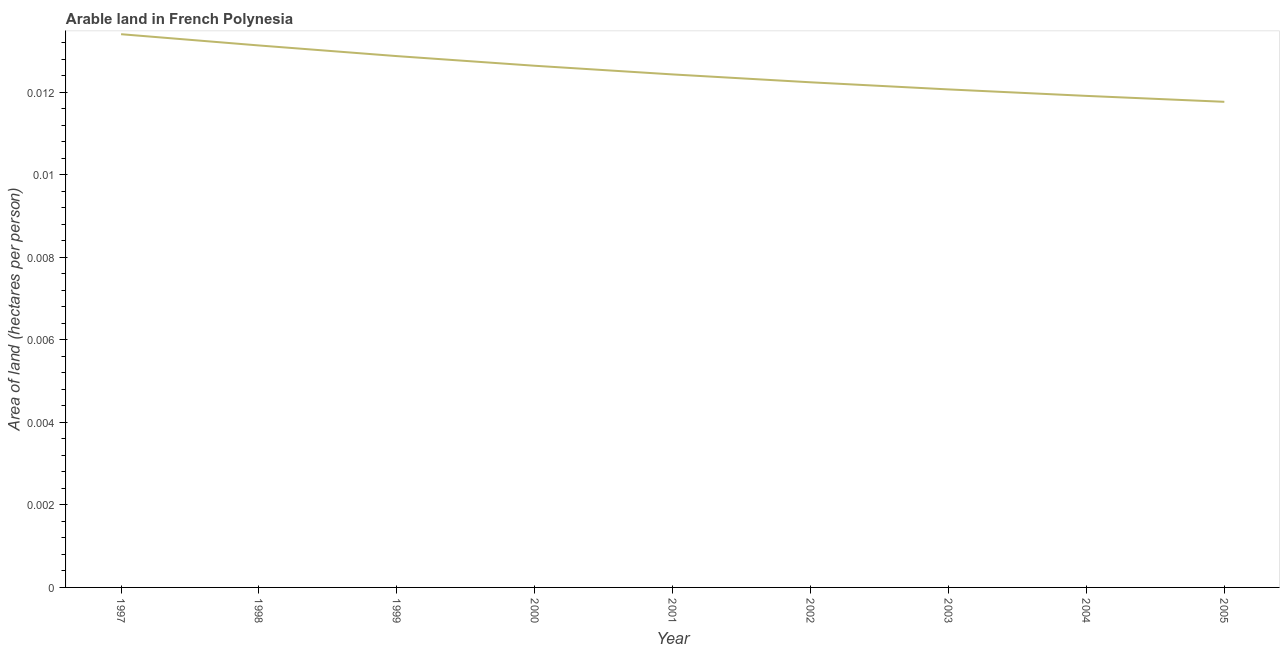What is the area of arable land in 2004?
Ensure brevity in your answer.  0.01. Across all years, what is the maximum area of arable land?
Your response must be concise. 0.01. Across all years, what is the minimum area of arable land?
Give a very brief answer. 0.01. In which year was the area of arable land maximum?
Provide a short and direct response. 1997. What is the sum of the area of arable land?
Your response must be concise. 0.11. What is the difference between the area of arable land in 1999 and 2003?
Provide a short and direct response. 0. What is the average area of arable land per year?
Offer a very short reply. 0.01. What is the median area of arable land?
Your answer should be compact. 0.01. In how many years, is the area of arable land greater than 0.0056 hectares per person?
Provide a succinct answer. 9. Do a majority of the years between 2001 and 2005 (inclusive) have area of arable land greater than 0.0052 hectares per person?
Provide a short and direct response. Yes. What is the ratio of the area of arable land in 1997 to that in 1999?
Ensure brevity in your answer.  1.04. Is the difference between the area of arable land in 1998 and 2005 greater than the difference between any two years?
Ensure brevity in your answer.  No. What is the difference between the highest and the second highest area of arable land?
Ensure brevity in your answer.  0. What is the difference between the highest and the lowest area of arable land?
Your answer should be very brief. 0. In how many years, is the area of arable land greater than the average area of arable land taken over all years?
Give a very brief answer. 4. What is the difference between two consecutive major ticks on the Y-axis?
Your answer should be compact. 0. Are the values on the major ticks of Y-axis written in scientific E-notation?
Provide a short and direct response. No. Does the graph contain any zero values?
Make the answer very short. No. Does the graph contain grids?
Give a very brief answer. No. What is the title of the graph?
Provide a succinct answer. Arable land in French Polynesia. What is the label or title of the Y-axis?
Your response must be concise. Area of land (hectares per person). What is the Area of land (hectares per person) of 1997?
Keep it short and to the point. 0.01. What is the Area of land (hectares per person) of 1998?
Provide a short and direct response. 0.01. What is the Area of land (hectares per person) in 1999?
Make the answer very short. 0.01. What is the Area of land (hectares per person) of 2000?
Your answer should be compact. 0.01. What is the Area of land (hectares per person) of 2001?
Make the answer very short. 0.01. What is the Area of land (hectares per person) in 2002?
Make the answer very short. 0.01. What is the Area of land (hectares per person) in 2003?
Your response must be concise. 0.01. What is the Area of land (hectares per person) of 2004?
Make the answer very short. 0.01. What is the Area of land (hectares per person) of 2005?
Give a very brief answer. 0.01. What is the difference between the Area of land (hectares per person) in 1997 and 1998?
Offer a terse response. 0. What is the difference between the Area of land (hectares per person) in 1997 and 1999?
Keep it short and to the point. 0. What is the difference between the Area of land (hectares per person) in 1997 and 2000?
Provide a succinct answer. 0. What is the difference between the Area of land (hectares per person) in 1997 and 2001?
Ensure brevity in your answer.  0. What is the difference between the Area of land (hectares per person) in 1997 and 2002?
Give a very brief answer. 0. What is the difference between the Area of land (hectares per person) in 1997 and 2003?
Make the answer very short. 0. What is the difference between the Area of land (hectares per person) in 1997 and 2004?
Your answer should be very brief. 0. What is the difference between the Area of land (hectares per person) in 1997 and 2005?
Make the answer very short. 0. What is the difference between the Area of land (hectares per person) in 1998 and 1999?
Your response must be concise. 0. What is the difference between the Area of land (hectares per person) in 1998 and 2000?
Offer a very short reply. 0. What is the difference between the Area of land (hectares per person) in 1998 and 2001?
Your response must be concise. 0. What is the difference between the Area of land (hectares per person) in 1998 and 2002?
Provide a short and direct response. 0. What is the difference between the Area of land (hectares per person) in 1998 and 2003?
Your answer should be compact. 0. What is the difference between the Area of land (hectares per person) in 1998 and 2004?
Make the answer very short. 0. What is the difference between the Area of land (hectares per person) in 1998 and 2005?
Keep it short and to the point. 0. What is the difference between the Area of land (hectares per person) in 1999 and 2000?
Keep it short and to the point. 0. What is the difference between the Area of land (hectares per person) in 1999 and 2001?
Offer a terse response. 0. What is the difference between the Area of land (hectares per person) in 1999 and 2002?
Ensure brevity in your answer.  0. What is the difference between the Area of land (hectares per person) in 1999 and 2003?
Ensure brevity in your answer.  0. What is the difference between the Area of land (hectares per person) in 1999 and 2004?
Your answer should be compact. 0. What is the difference between the Area of land (hectares per person) in 1999 and 2005?
Provide a short and direct response. 0. What is the difference between the Area of land (hectares per person) in 2000 and 2001?
Your answer should be very brief. 0. What is the difference between the Area of land (hectares per person) in 2000 and 2002?
Your answer should be very brief. 0. What is the difference between the Area of land (hectares per person) in 2000 and 2003?
Provide a short and direct response. 0. What is the difference between the Area of land (hectares per person) in 2000 and 2004?
Keep it short and to the point. 0. What is the difference between the Area of land (hectares per person) in 2000 and 2005?
Provide a short and direct response. 0. What is the difference between the Area of land (hectares per person) in 2001 and 2002?
Keep it short and to the point. 0. What is the difference between the Area of land (hectares per person) in 2001 and 2003?
Keep it short and to the point. 0. What is the difference between the Area of land (hectares per person) in 2001 and 2004?
Keep it short and to the point. 0. What is the difference between the Area of land (hectares per person) in 2001 and 2005?
Your answer should be compact. 0. What is the difference between the Area of land (hectares per person) in 2002 and 2003?
Your answer should be very brief. 0. What is the difference between the Area of land (hectares per person) in 2002 and 2004?
Keep it short and to the point. 0. What is the difference between the Area of land (hectares per person) in 2002 and 2005?
Your response must be concise. 0. What is the difference between the Area of land (hectares per person) in 2003 and 2004?
Ensure brevity in your answer.  0. What is the difference between the Area of land (hectares per person) in 2003 and 2005?
Your answer should be compact. 0. What is the difference between the Area of land (hectares per person) in 2004 and 2005?
Provide a short and direct response. 0. What is the ratio of the Area of land (hectares per person) in 1997 to that in 1999?
Give a very brief answer. 1.04. What is the ratio of the Area of land (hectares per person) in 1997 to that in 2000?
Offer a terse response. 1.06. What is the ratio of the Area of land (hectares per person) in 1997 to that in 2001?
Offer a terse response. 1.08. What is the ratio of the Area of land (hectares per person) in 1997 to that in 2002?
Give a very brief answer. 1.09. What is the ratio of the Area of land (hectares per person) in 1997 to that in 2003?
Your answer should be very brief. 1.11. What is the ratio of the Area of land (hectares per person) in 1997 to that in 2005?
Ensure brevity in your answer.  1.14. What is the ratio of the Area of land (hectares per person) in 1998 to that in 2000?
Offer a very short reply. 1.04. What is the ratio of the Area of land (hectares per person) in 1998 to that in 2001?
Provide a short and direct response. 1.06. What is the ratio of the Area of land (hectares per person) in 1998 to that in 2002?
Give a very brief answer. 1.07. What is the ratio of the Area of land (hectares per person) in 1998 to that in 2003?
Make the answer very short. 1.09. What is the ratio of the Area of land (hectares per person) in 1998 to that in 2004?
Your answer should be very brief. 1.1. What is the ratio of the Area of land (hectares per person) in 1998 to that in 2005?
Give a very brief answer. 1.12. What is the ratio of the Area of land (hectares per person) in 1999 to that in 2000?
Provide a short and direct response. 1.02. What is the ratio of the Area of land (hectares per person) in 1999 to that in 2001?
Offer a terse response. 1.04. What is the ratio of the Area of land (hectares per person) in 1999 to that in 2002?
Offer a terse response. 1.05. What is the ratio of the Area of land (hectares per person) in 1999 to that in 2003?
Ensure brevity in your answer.  1.07. What is the ratio of the Area of land (hectares per person) in 1999 to that in 2004?
Make the answer very short. 1.08. What is the ratio of the Area of land (hectares per person) in 1999 to that in 2005?
Your answer should be very brief. 1.09. What is the ratio of the Area of land (hectares per person) in 2000 to that in 2002?
Provide a succinct answer. 1.03. What is the ratio of the Area of land (hectares per person) in 2000 to that in 2003?
Make the answer very short. 1.05. What is the ratio of the Area of land (hectares per person) in 2000 to that in 2004?
Give a very brief answer. 1.06. What is the ratio of the Area of land (hectares per person) in 2000 to that in 2005?
Your answer should be very brief. 1.07. What is the ratio of the Area of land (hectares per person) in 2001 to that in 2004?
Your answer should be compact. 1.04. What is the ratio of the Area of land (hectares per person) in 2001 to that in 2005?
Provide a succinct answer. 1.06. What is the ratio of the Area of land (hectares per person) in 2002 to that in 2003?
Provide a succinct answer. 1.01. What is the ratio of the Area of land (hectares per person) in 2002 to that in 2004?
Provide a short and direct response. 1.03. What is the ratio of the Area of land (hectares per person) in 2003 to that in 2004?
Your response must be concise. 1.01. What is the ratio of the Area of land (hectares per person) in 2004 to that in 2005?
Ensure brevity in your answer.  1.01. 